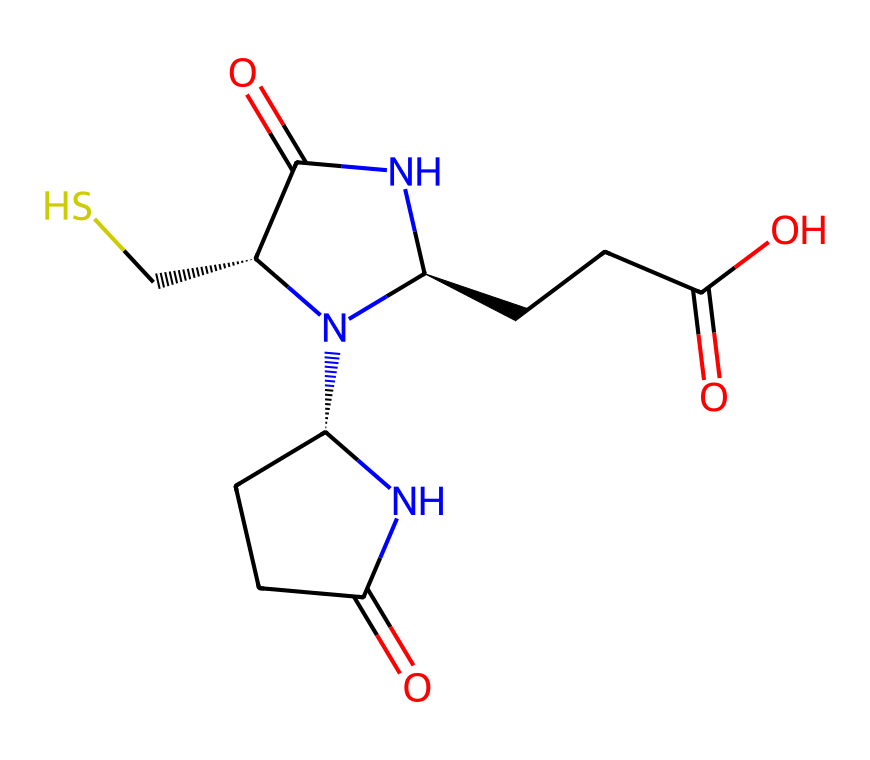What is the molecular formula of biotin? To determine the molecular formula from the SMILES notation, we identify the atoms present. The notation indicates that there are carbon (C), hydrogen (H), nitrogen (N), oxygen (O), and sulfur (S) atoms. Counting all the atoms from the structure gives C10H16N2O3S.
Answer: C10H16N2O3S How many nitrogen atoms are present in biotin? Analyzing the SMILES representation, we can see two nitrogen atoms (indicated by 'N'). Hence, the number of nitrogen atoms is counted directly from the structure.
Answer: 2 What type of functional group is indicated by the "C=O" in the structure? The "C=O" in the structure represents a carbonyl group, which is characteristic of aldehydes, ketones, and carboxylic acids. Since biotin contains both carboxylic acids and amide groups, the analysis confirms the presence of this functional group.
Answer: carbonyl What is the significance of the sulfur atom in biotin? The presence of the sulfur atom in biotin designates its role as a coenzyme in metabolic processes, specifically in the carboxylation reactions in fatty acid synthesis and amino acid metabolism. This is a key function that makes biotin essential for human health.
Answer: coenzyme Which stereocenter is indicated by "[C@H]" in the structure? The "[C@H]" notation indicates a chiral carbon atom, which is a stereocenter. By analyzing the stereochemistry shown in the SMILES representation, we identify that this carbon is attached to specific substituents, leading to different stereoisomers.
Answer: chiral carbon How many carboxylic acid groups are present in biotin? Upon inspecting the structure, we find one carboxylic acid group, which is indicated by the "-COOH" pattern. Thus, counting the functional groups reveals that there is only one such group in the molecule.
Answer: 1 